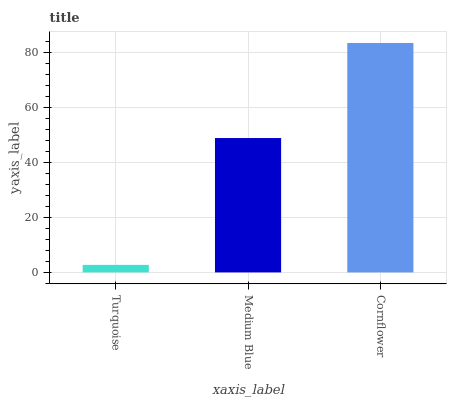Is Turquoise the minimum?
Answer yes or no. Yes. Is Cornflower the maximum?
Answer yes or no. Yes. Is Medium Blue the minimum?
Answer yes or no. No. Is Medium Blue the maximum?
Answer yes or no. No. Is Medium Blue greater than Turquoise?
Answer yes or no. Yes. Is Turquoise less than Medium Blue?
Answer yes or no. Yes. Is Turquoise greater than Medium Blue?
Answer yes or no. No. Is Medium Blue less than Turquoise?
Answer yes or no. No. Is Medium Blue the high median?
Answer yes or no. Yes. Is Medium Blue the low median?
Answer yes or no. Yes. Is Cornflower the high median?
Answer yes or no. No. Is Turquoise the low median?
Answer yes or no. No. 